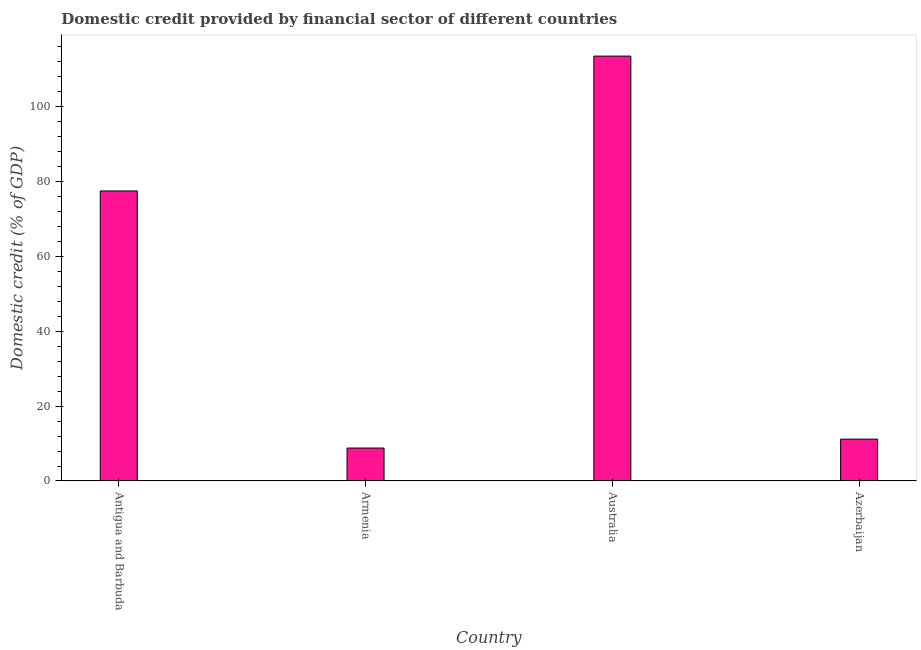What is the title of the graph?
Give a very brief answer. Domestic credit provided by financial sector of different countries. What is the label or title of the Y-axis?
Keep it short and to the point. Domestic credit (% of GDP). What is the domestic credit provided by financial sector in Armenia?
Offer a very short reply. 8.79. Across all countries, what is the maximum domestic credit provided by financial sector?
Your answer should be very brief. 113.37. Across all countries, what is the minimum domestic credit provided by financial sector?
Your answer should be very brief. 8.79. In which country was the domestic credit provided by financial sector maximum?
Your answer should be very brief. Australia. In which country was the domestic credit provided by financial sector minimum?
Offer a terse response. Armenia. What is the sum of the domestic credit provided by financial sector?
Your answer should be very brief. 210.72. What is the difference between the domestic credit provided by financial sector in Antigua and Barbuda and Azerbaijan?
Keep it short and to the point. 66.23. What is the average domestic credit provided by financial sector per country?
Ensure brevity in your answer.  52.68. What is the median domestic credit provided by financial sector?
Keep it short and to the point. 44.28. What is the ratio of the domestic credit provided by financial sector in Antigua and Barbuda to that in Azerbaijan?
Offer a terse response. 6.93. What is the difference between the highest and the second highest domestic credit provided by financial sector?
Your answer should be compact. 35.98. Is the sum of the domestic credit provided by financial sector in Armenia and Australia greater than the maximum domestic credit provided by financial sector across all countries?
Offer a terse response. Yes. What is the difference between the highest and the lowest domestic credit provided by financial sector?
Provide a short and direct response. 104.58. In how many countries, is the domestic credit provided by financial sector greater than the average domestic credit provided by financial sector taken over all countries?
Ensure brevity in your answer.  2. What is the difference between two consecutive major ticks on the Y-axis?
Offer a terse response. 20. Are the values on the major ticks of Y-axis written in scientific E-notation?
Provide a short and direct response. No. What is the Domestic credit (% of GDP) in Antigua and Barbuda?
Keep it short and to the point. 77.39. What is the Domestic credit (% of GDP) of Armenia?
Keep it short and to the point. 8.79. What is the Domestic credit (% of GDP) in Australia?
Your response must be concise. 113.37. What is the Domestic credit (% of GDP) in Azerbaijan?
Your answer should be compact. 11.17. What is the difference between the Domestic credit (% of GDP) in Antigua and Barbuda and Armenia?
Provide a short and direct response. 68.6. What is the difference between the Domestic credit (% of GDP) in Antigua and Barbuda and Australia?
Offer a very short reply. -35.98. What is the difference between the Domestic credit (% of GDP) in Antigua and Barbuda and Azerbaijan?
Give a very brief answer. 66.23. What is the difference between the Domestic credit (% of GDP) in Armenia and Australia?
Your answer should be compact. -104.58. What is the difference between the Domestic credit (% of GDP) in Armenia and Azerbaijan?
Your response must be concise. -2.38. What is the difference between the Domestic credit (% of GDP) in Australia and Azerbaijan?
Your answer should be compact. 102.21. What is the ratio of the Domestic credit (% of GDP) in Antigua and Barbuda to that in Armenia?
Provide a succinct answer. 8.81. What is the ratio of the Domestic credit (% of GDP) in Antigua and Barbuda to that in Australia?
Provide a succinct answer. 0.68. What is the ratio of the Domestic credit (% of GDP) in Antigua and Barbuda to that in Azerbaijan?
Offer a very short reply. 6.93. What is the ratio of the Domestic credit (% of GDP) in Armenia to that in Australia?
Provide a short and direct response. 0.08. What is the ratio of the Domestic credit (% of GDP) in Armenia to that in Azerbaijan?
Your answer should be compact. 0.79. What is the ratio of the Domestic credit (% of GDP) in Australia to that in Azerbaijan?
Your answer should be compact. 10.15. 